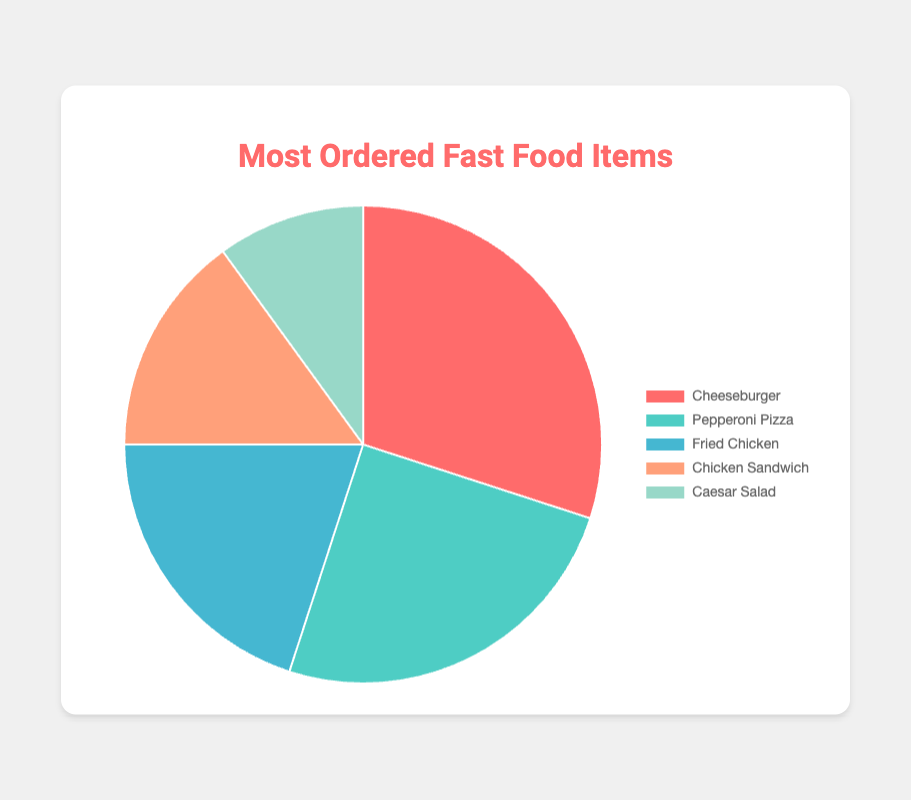Which fast food item is the most ordered? The slice of the chart representing Cheeseburger is the largest, indicating it has the highest percentage.
Answer: Cheeseburger What is the total percentage of orders for Sandwiches and Salads combined? The percentage for Sandwiches is 15% and for Salads is 10%. Adding these together gives 15% + 10% = 25%.
Answer: 25% Is Pepperoni Pizza ordered more or less frequently than Caesar Salad? The percentage for Pepperoni Pizza is 25%, while for Caesar Salad it is 10%. Since 25% is greater than 10%, Pepperoni Pizza is ordered more frequently.
Answer: More What is the percentage difference between orders for Fried Chicken and Chicken Sandwich? The percentage for Fried Chicken is 20% and for Chicken Sandwich it is 15%. The difference is 20% - 15% = 5%.
Answer: 5% Which fast food item has the smallest ordering percentage? The slice of the chart representing Caesar Salad is the smallest, indicating it has the lowest percentage.
Answer: Caesar Salad Is the percentage of Cheeseburger orders greater than the combined percentages of Chicken Sandwich and Caesar Salad? The percentage for Cheeseburger is 30%. The combined percentage for Chicken Sandwich and Caesar Salad is 15% + 10% = 25%. Since 30% is greater than 25%, Cheeseburger has a higher percentage.
Answer: Yes Rank the fast food items from most ordered to least ordered. From the chart, the descending order of percentages is Cheeseburger (30%), Pepperoni Pizza (25%), Fried Chicken (20%), Chicken Sandwich (15%), and Caesar Salad (10%).
Answer: Cheeseburger, Pepperoni Pizza, Fried Chicken, Chicken Sandwich, Caesar Salad What are the cumulative orders' percentages of items that account for at least 20% each? Cheeseburger (30%), Pepperoni Pizza (25%), and Fried Chicken (20%) each account for 20% or more. Summing these gives 30% + 25% + 20% = 75%.
Answer: 75% Which visual attribute corresponds to the least ordered item? The smallest slice in the pie chart represents the category with the lowest percentage, which is Caesar Salad.
Answer: Smallest slice 